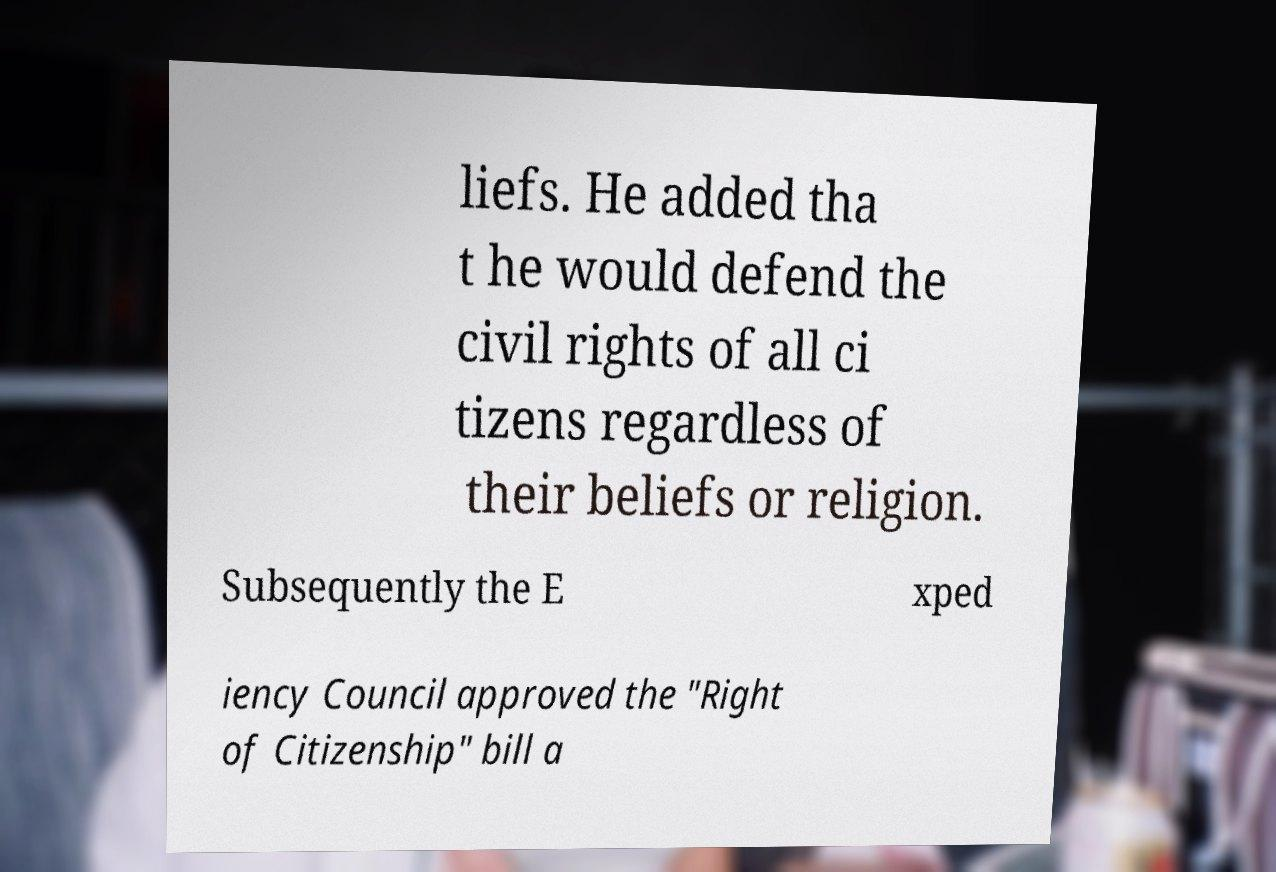For documentation purposes, I need the text within this image transcribed. Could you provide that? liefs. He added tha t he would defend the civil rights of all ci tizens regardless of their beliefs or religion. Subsequently the E xped iency Council approved the "Right of Citizenship" bill a 